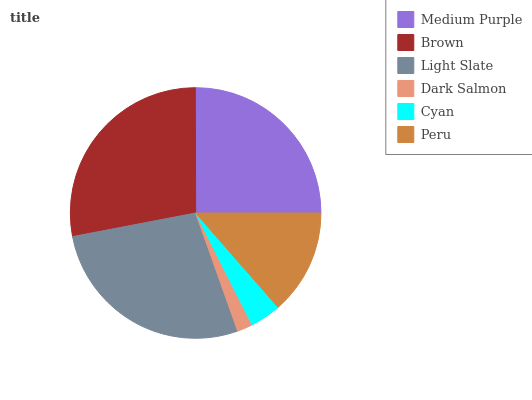Is Dark Salmon the minimum?
Answer yes or no. Yes. Is Brown the maximum?
Answer yes or no. Yes. Is Light Slate the minimum?
Answer yes or no. No. Is Light Slate the maximum?
Answer yes or no. No. Is Brown greater than Light Slate?
Answer yes or no. Yes. Is Light Slate less than Brown?
Answer yes or no. Yes. Is Light Slate greater than Brown?
Answer yes or no. No. Is Brown less than Light Slate?
Answer yes or no. No. Is Medium Purple the high median?
Answer yes or no. Yes. Is Peru the low median?
Answer yes or no. Yes. Is Light Slate the high median?
Answer yes or no. No. Is Light Slate the low median?
Answer yes or no. No. 